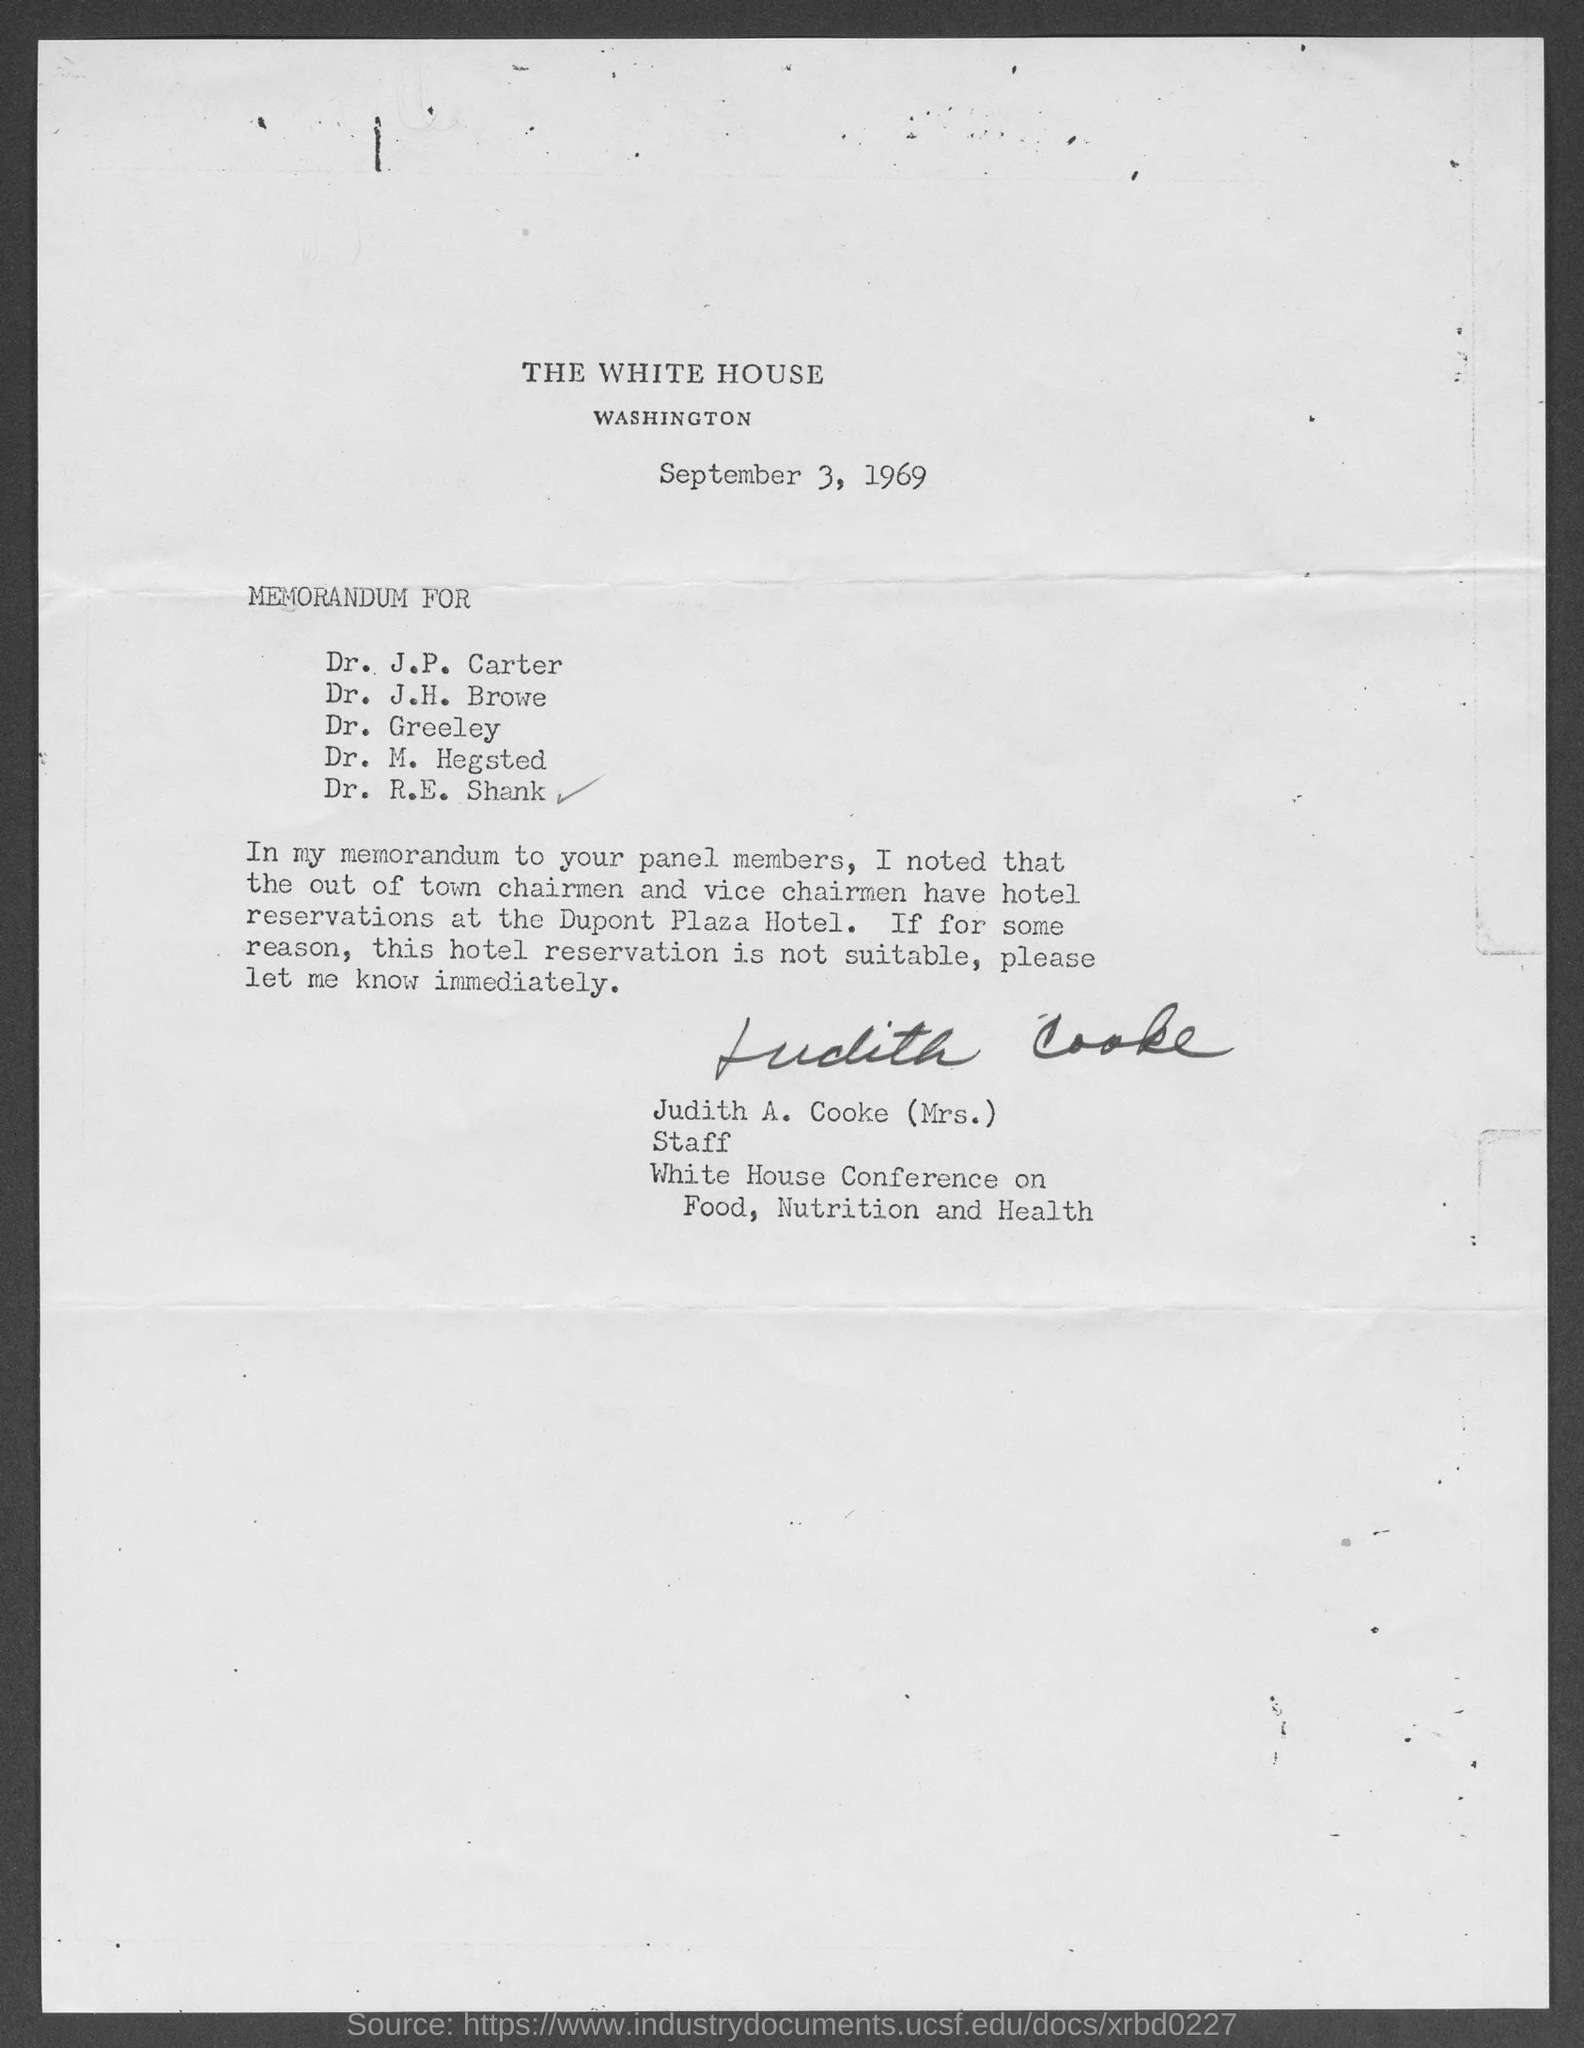Outline some significant characteristics in this image. The White House conference on Food, Nutrition and Health was attended by Judith A. Cooke (Mrs.), who was the staff. 